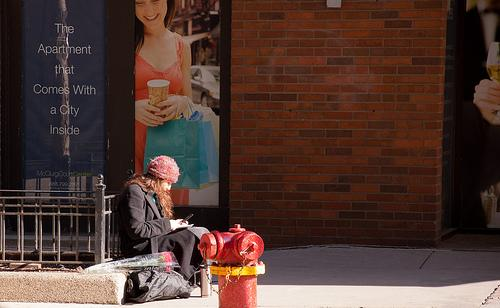Describe one particular feature of the woman sitting against the railing. The woman sitting against the railing has long brown hair. Mention an advertisement in the image, and what it is promoting. There's a poster with an apartment advertisement on it. How many objects in the image are related to fire hydrants, and briefly describe them? Four objects are related to fire hydrants: a red and yellow fire hydrant, a fire hydrant on the sidewalk, a red fire hydrant with a yellow strip, and another red fire hydrant. What are some items associated with flowers in this image? There are roses lying next to a woman and a bouquet of roses in plastic. List the different types of women depicted in this image. Woman holding paper coffee cup, woman with blue shopping bag, woman sitting and writing, woman in black coat, woman wearing red cap, woman sitting against black railing, woman wearing a winter coat, and woman sitting on a curbside. What type of coat is one of the women in the image wearing? One woman is wearing a black winter coat. What is the color and type of the hat the woman in the image is wearing? The woman is wearing a red beanie on her head. What object in the image is related to wine? There's a picture of a person's hand holding a glass of wine. In a single sentence, describe the type of wall in the image. The image features a red brick wall of different colors in the background. Which objects are depicted in close proximity to the fire hydrant? There's a chain on the fire hydrant and a crack on the sidewalk nearby. What is in the woman's hand? The woman is holding a cellphone. What are the dimensions of the woman in the image? X:113 Y:154 Width:100 Height:100 What is the girl's hair color? The girl has long brown hair. Is the red fire hydrant leaning against the metal gate? The red fire hydrant (X:198 Y:225) has a different position from the metal gate (X:0 Y:181), making this instruction misleading as it implies that the fire hydrant is leaning against the gate when it's not. Are there any visible cracks on the sidewalk? Yes, there is a crack on the sidewalk. How many people are in the image? There is one person in the image. Rate the quality of the image on a scale of 1 to 5, with 5 being the highest. 4 Where are the red roses resting? The red roses are resting on the black backpack. Which object is larger: the red brick wall or the metal gate? The red brick wall is larger. Identify the object referred to as "chains on the side of the fire hydrant." X:197 Y:234 Width:55 Height:55 Does the woman wearing a winter coat have the bouquet of roses in her hand? In the image details, the winter coat and bouquet of roses are separate and not connected. The woman wearing the winter coat is in position (X:122 Y:175) and the bouquet of roses is in the position (X:73 Y:250). This instruction is misleading as it implies that the woman is holding the roses when she's not. What kind of building is next to the sidewalk? There is a red brick building next to the sidewalk. Is the woman with the blue shopping bag sitting on the ground? In the image details, the woman with the blue shopping bag has a different position (X:128 Y:4) from the sitting woman (X:121 Y:153), making it misleading as it implies the woman with the shopping bag is sitting when she's not. What is the object with dimensions: X:196 Y:246 Width:301 Height:301? It is the shadow from the building on the ground. Classify the areas of the image that show a black coat worn by the woman. X:118 Y:181 Width:51 Height:51 Read the text on the poster with an apartment advertisement. Sorry, the text is not visible in the image. Is there anything unusual about the brick wall? Yes, the bricks are of different colors. Is the apartment advertisement poster hanging on the red brick wall? The apartment advertisement poster (X:20 Y:1) is not on the red brick wall (X:244 Y:14), making this instruction misleading as it implies that the poster is hanging on the wall. What sentiment is conveyed by the image? The image conveys a calm and peaceful sentiment. Does the fire hydrant have any distinctive marks? The fire hydrant has a yellow strip. Identify the object referred to as "a bouquet of roses in plastic". X:73 Y:250 Width:107 Height:107 What color is the hat the woman is wearing? The hat is red. Can you see the pink hat on the fire hydrant? The pink hat is described as being on the girl's head (X:143 Y:153), not on the fire hydrant (X:198 Y:225), making this instruction confusing and incorrect. Describe the scene in the image. A woman is sitting on a sidewalk with roses lying next to her and a black backpack on the ground. A red brick wall, a red fire hydrant, a woman holding a shopping bag, and posters of women are also visible. How does the woman interact with her environment? The woman is sitting on the sidewalk, leaning against a metal railing, and holding a phone in her hand. Is the crack on the sidewalk in front of the red brick wall? The crack on the sidewalk (X:452 Y:257) has a different position from the red brick wall (X:244 Y:14), implying that the crack is in front of the wall when it's not. 